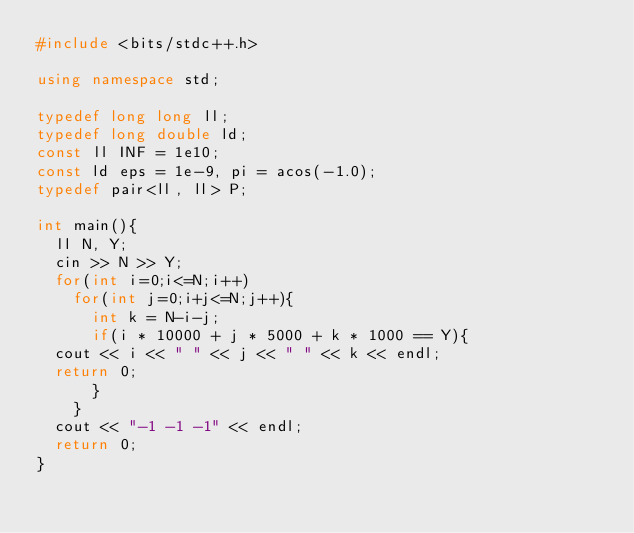<code> <loc_0><loc_0><loc_500><loc_500><_C++_>#include <bits/stdc++.h>

using namespace std;

typedef long long ll;
typedef long double ld;
const ll INF = 1e10;
const ld eps = 1e-9, pi = acos(-1.0);
typedef pair<ll, ll> P;

int main(){
  ll N, Y;
  cin >> N >> Y;
  for(int i=0;i<=N;i++)
    for(int j=0;i+j<=N;j++){
      int k = N-i-j;
      if(i * 10000 + j * 5000 + k * 1000 == Y){
	cout << i << " " << j << " " << k << endl;
	return 0;
      }
    }
  cout << "-1 -1 -1" << endl;
  return 0;
}
</code> 